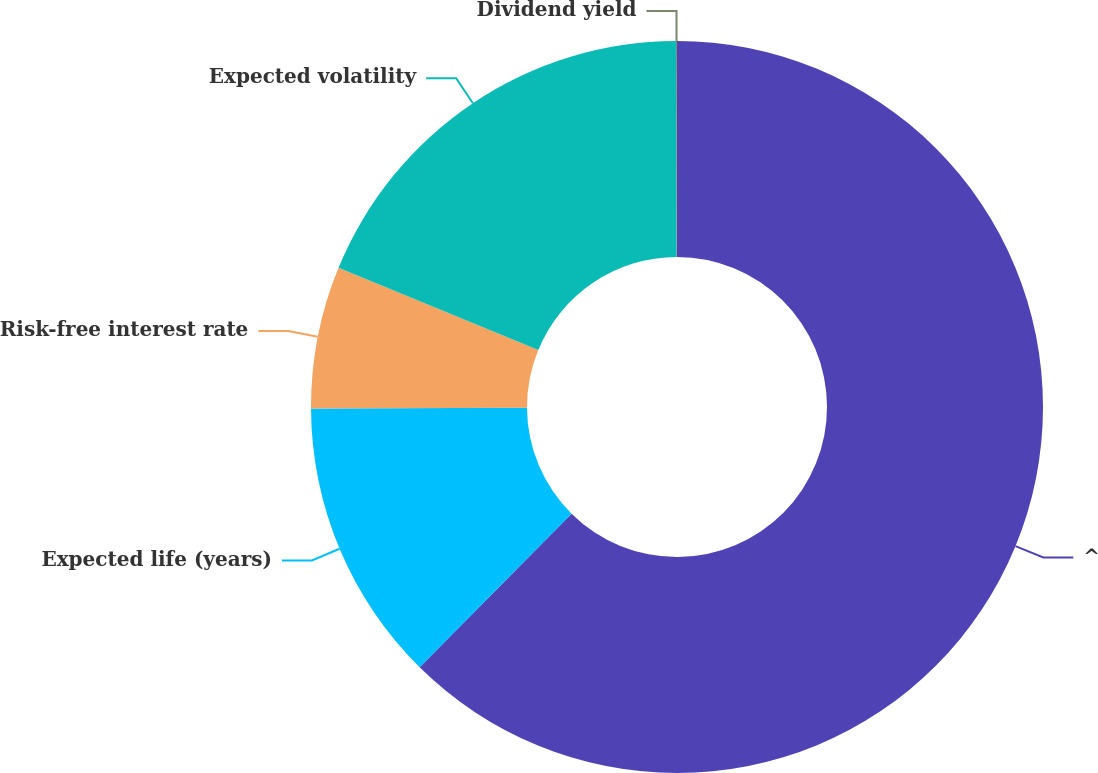Convert chart to OTSL. <chart><loc_0><loc_0><loc_500><loc_500><pie_chart><fcel>^<fcel>Expected life (years)<fcel>Risk-free interest rate<fcel>Expected volatility<fcel>Dividend yield<nl><fcel>62.41%<fcel>12.52%<fcel>6.28%<fcel>18.75%<fcel>0.04%<nl></chart> 